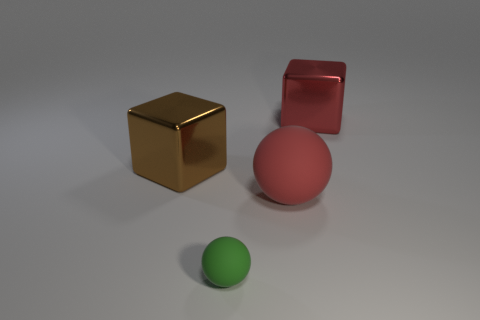Add 1 green balls. How many objects exist? 5 Subtract all spheres. Subtract all green matte spheres. How many objects are left? 1 Add 2 large red objects. How many large red objects are left? 4 Add 2 metallic things. How many metallic things exist? 4 Subtract 0 gray cylinders. How many objects are left? 4 